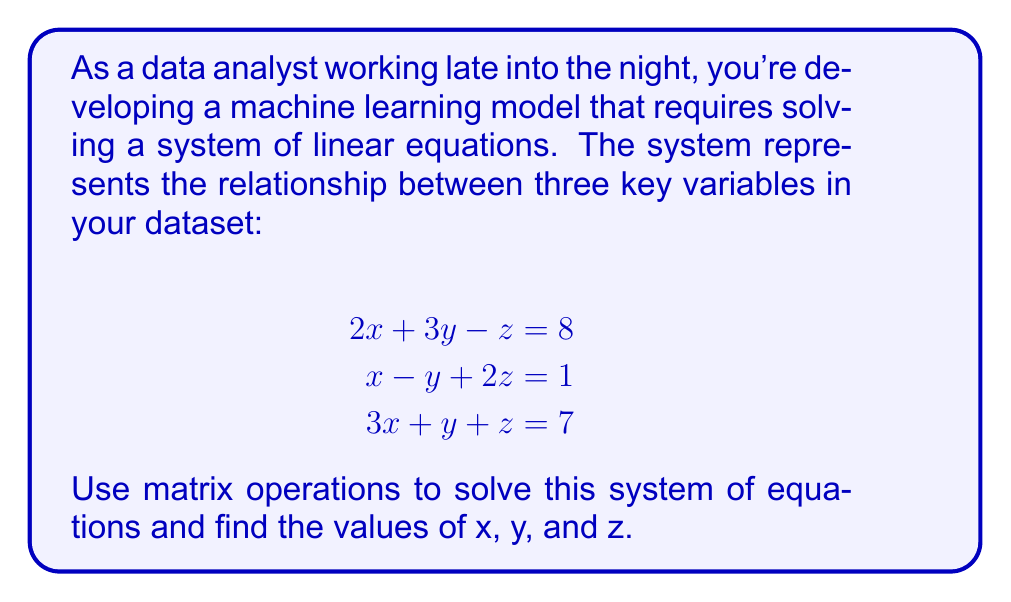What is the answer to this math problem? Let's solve this system using matrix operations:

1) First, we'll set up the augmented matrix:

   $$\begin{bmatrix}
   2 & 3 & -1 & | & 8 \\
   1 & -1 & 2 & | & 1 \\
   3 & 1 & 1 & | & 7
   \end{bmatrix}$$

2) Now, we'll perform row operations to get the matrix in row echelon form:
   
   R2 → R2 - 0.5R1:
   $$\begin{bmatrix}
   2 & 3 & -1 & | & 8 \\
   0 & -2.5 & 2.5 & | & -3 \\
   3 & 1 & 1 & | & 7
   \end{bmatrix}$$

   R3 → R3 - 1.5R1:
   $$\begin{bmatrix}
   2 & 3 & -1 & | & 8 \\
   0 & -2.5 & 2.5 & | & -3 \\
   0 & -3.5 & 2.5 & | & -5
   \end{bmatrix}$$

3) Continue row operations:
   
   R3 → R3 - 1.4R2:
   $$\begin{bmatrix}
   2 & 3 & -1 & | & 8 \\
   0 & -2.5 & 2.5 & | & -3 \\
   0 & 0 & -1 & | & -0.8
   \end{bmatrix}$$

4) Now we have the matrix in row echelon form. Let's solve for z, y, and x:

   z = 0.8
   
   -2.5y + 2.5(0.8) = -3
   -2.5y = -3 - 2
   -2.5y = -5
   y = 2
   
   2x + 3(2) - 0.8 = 8
   2x + 6 - 0.8 = 8
   2x = 2.8
   x = 1.4

5) Therefore, the solution is x = 1.4, y = 2, and z = 0.8.
Answer: x = 1.4, y = 2, z = 0.8 